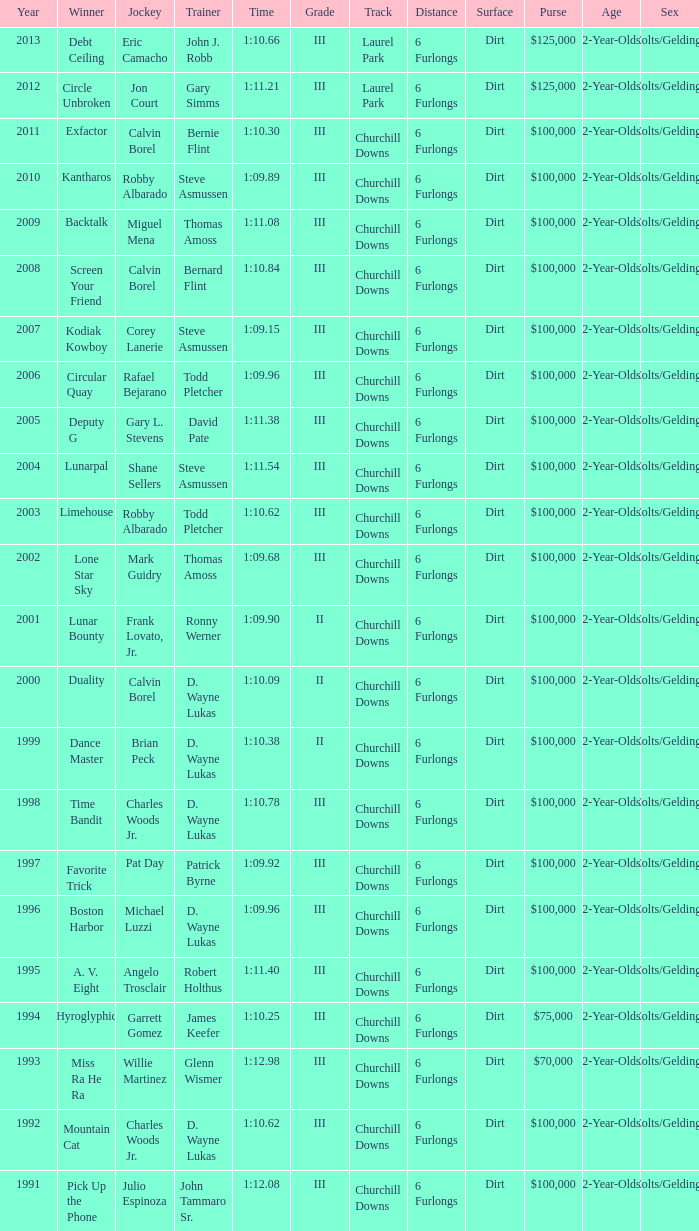Would you mind parsing the complete table? {'header': ['Year', 'Winner', 'Jockey', 'Trainer', 'Time', 'Grade', 'Track', 'Distance', 'Surface', 'Purse', 'Age', 'Sex'], 'rows': [['2013', 'Debt Ceiling', 'Eric Camacho', 'John J. Robb', '1:10.66', 'III', 'Laurel Park', '6 Furlongs', 'Dirt', '$125,000', '2-Year-Olds', 'Colts/Geldings'], ['2012', 'Circle Unbroken', 'Jon Court', 'Gary Simms', '1:11.21', 'III', 'Laurel Park', '6 Furlongs', 'Dirt', '$125,000', '2-Year-Olds', 'Colts/Geldings'], ['2011', 'Exfactor', 'Calvin Borel', 'Bernie Flint', '1:10.30', 'III', 'Churchill Downs', '6 Furlongs', 'Dirt', '$100,000', '2-Year-Olds', 'Colts/Geldings'], ['2010', 'Kantharos', 'Robby Albarado', 'Steve Asmussen', '1:09.89', 'III', 'Churchill Downs', '6 Furlongs', 'Dirt', '$100,000', '2-Year-Olds', 'Colts/Geldings'], ['2009', 'Backtalk', 'Miguel Mena', 'Thomas Amoss', '1:11.08', 'III', 'Churchill Downs', '6 Furlongs', 'Dirt', '$100,000', '2-Year-Olds', 'Colts/Geldings'], ['2008', 'Screen Your Friend', 'Calvin Borel', 'Bernard Flint', '1:10.84', 'III', 'Churchill Downs', '6 Furlongs', 'Dirt', '$100,000', '2-Year-Olds', 'Colts/Geldings'], ['2007', 'Kodiak Kowboy', 'Corey Lanerie', 'Steve Asmussen', '1:09.15', 'III', 'Churchill Downs', '6 Furlongs', 'Dirt', '$100,000', '2-Year-Olds', 'Colts/Geldings'], ['2006', 'Circular Quay', 'Rafael Bejarano', 'Todd Pletcher', '1:09.96', 'III', 'Churchill Downs', '6 Furlongs', 'Dirt', '$100,000', '2-Year-Olds', 'Colts/Geldings'], ['2005', 'Deputy G', 'Gary L. Stevens', 'David Pate', '1:11.38', 'III', 'Churchill Downs', '6 Furlongs', 'Dirt', '$100,000', '2-Year-Olds', 'Colts/Geldings'], ['2004', 'Lunarpal', 'Shane Sellers', 'Steve Asmussen', '1:11.54', 'III', 'Churchill Downs', '6 Furlongs', 'Dirt', '$100,000', '2-Year-Olds', 'Colts/Geldings'], ['2003', 'Limehouse', 'Robby Albarado', 'Todd Pletcher', '1:10.62', 'III', 'Churchill Downs', '6 Furlongs', 'Dirt', '$100,000', '2-Year-Olds', 'Colts/Geldings'], ['2002', 'Lone Star Sky', 'Mark Guidry', 'Thomas Amoss', '1:09.68', 'III', 'Churchill Downs', '6 Furlongs', 'Dirt', '$100,000', '2-Year-Olds', 'Colts/Geldings'], ['2001', 'Lunar Bounty', 'Frank Lovato, Jr.', 'Ronny Werner', '1:09.90', 'II', 'Churchill Downs', '6 Furlongs', 'Dirt', '$100,000', '2-Year-Olds', 'Colts/Geldings'], ['2000', 'Duality', 'Calvin Borel', 'D. Wayne Lukas', '1:10.09', 'II', 'Churchill Downs', '6 Furlongs', 'Dirt', '$100,000', '2-Year-Olds', 'Colts/Geldings'], ['1999', 'Dance Master', 'Brian Peck', 'D. Wayne Lukas', '1:10.38', 'II', 'Churchill Downs', '6 Furlongs', 'Dirt', '$100,000', '2-Year-Olds', 'Colts/Geldings'], ['1998', 'Time Bandit', 'Charles Woods Jr.', 'D. Wayne Lukas', '1:10.78', 'III', 'Churchill Downs', '6 Furlongs', 'Dirt', '$100,000', '2-Year-Olds', 'Colts/Geldings'], ['1997', 'Favorite Trick', 'Pat Day', 'Patrick Byrne', '1:09.92', 'III', 'Churchill Downs', '6 Furlongs', 'Dirt', '$100,000', '2-Year-Olds', 'Colts/Geldings'], ['1996', 'Boston Harbor', 'Michael Luzzi', 'D. Wayne Lukas', '1:09.96', 'III', 'Churchill Downs', '6 Furlongs', 'Dirt', '$100,000', '2-Year-Olds', 'Colts/Geldings'], ['1995', 'A. V. Eight', 'Angelo Trosclair', 'Robert Holthus', '1:11.40', 'III', 'Churchill Downs', '6 Furlongs', 'Dirt', '$100,000', '2-Year-Olds', 'Colts/Geldings'], ['1994', 'Hyroglyphic', 'Garrett Gomez', 'James Keefer', '1:10.25', 'III', 'Churchill Downs', '6 Furlongs', 'Dirt', '$75,000', '2-Year-Olds', 'Colts/Geldings'], ['1993', 'Miss Ra He Ra', 'Willie Martinez', 'Glenn Wismer', '1:12.98', 'III', 'Churchill Downs', '6 Furlongs', 'Dirt', '$70,000', '2-Year-Olds', 'Colts/Geldings'], ['1992', 'Mountain Cat', 'Charles Woods Jr.', 'D. Wayne Lukas', '1:10.62', 'III', 'Churchill Downs', '6 Furlongs', 'Dirt', '$100,000', '2-Year-Olds', 'Colts/Geldings'], ['1991', 'Pick Up the Phone', 'Julio Espinoza', 'John Tammaro Sr.', '1:12.08', 'III', 'Churchill Downs', '6 Furlongs', 'Dirt', '$100,000', '2-Year-Olds', 'Colts/Geldings']]} Before 2010, which trainer claimed victory in the hyroglyphic event? James Keefer. 